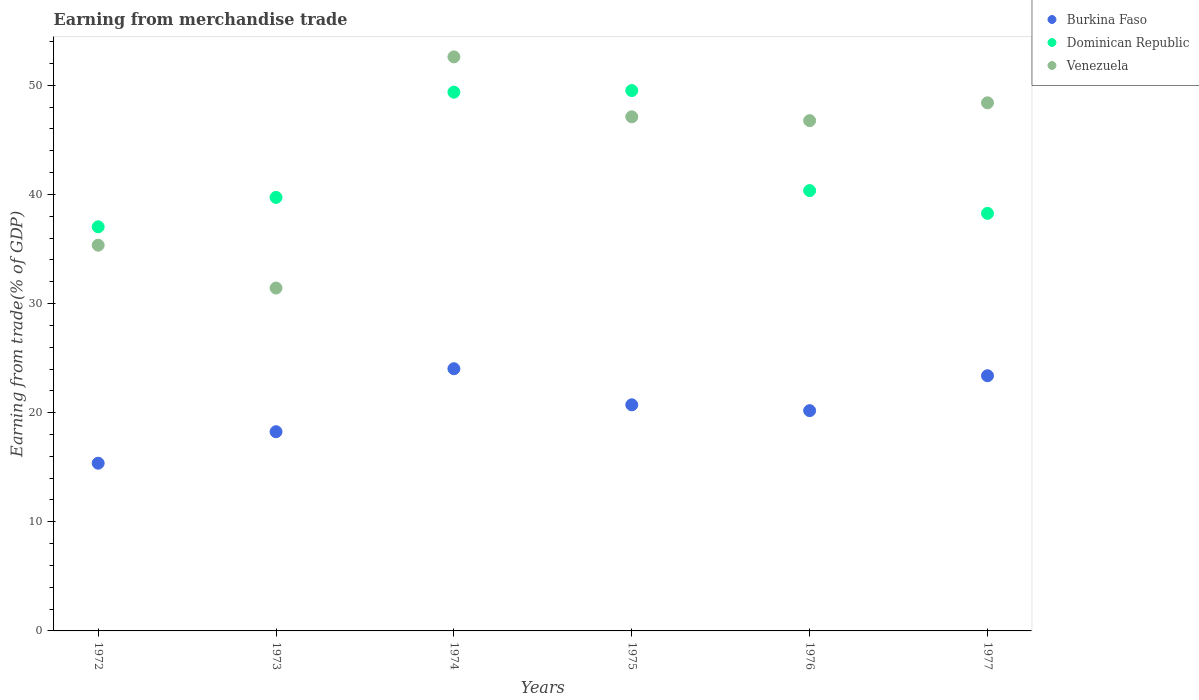What is the earnings from trade in Dominican Republic in 1975?
Provide a short and direct response. 49.52. Across all years, what is the maximum earnings from trade in Burkina Faso?
Provide a short and direct response. 24.03. Across all years, what is the minimum earnings from trade in Burkina Faso?
Offer a very short reply. 15.37. In which year was the earnings from trade in Dominican Republic maximum?
Your answer should be compact. 1975. What is the total earnings from trade in Burkina Faso in the graph?
Provide a short and direct response. 121.94. What is the difference between the earnings from trade in Venezuela in 1974 and that in 1975?
Ensure brevity in your answer.  5.49. What is the difference between the earnings from trade in Venezuela in 1976 and the earnings from trade in Burkina Faso in 1974?
Provide a short and direct response. 22.74. What is the average earnings from trade in Dominican Republic per year?
Provide a succinct answer. 42.38. In the year 1977, what is the difference between the earnings from trade in Venezuela and earnings from trade in Burkina Faso?
Keep it short and to the point. 25.01. What is the ratio of the earnings from trade in Burkina Faso in 1972 to that in 1976?
Offer a very short reply. 0.76. Is the difference between the earnings from trade in Venezuela in 1974 and 1976 greater than the difference between the earnings from trade in Burkina Faso in 1974 and 1976?
Provide a succinct answer. Yes. What is the difference between the highest and the second highest earnings from trade in Burkina Faso?
Ensure brevity in your answer.  0.64. What is the difference between the highest and the lowest earnings from trade in Dominican Republic?
Provide a succinct answer. 12.49. Is the sum of the earnings from trade in Venezuela in 1972 and 1976 greater than the maximum earnings from trade in Dominican Republic across all years?
Offer a terse response. Yes. Does the earnings from trade in Venezuela monotonically increase over the years?
Offer a terse response. No. How many dotlines are there?
Ensure brevity in your answer.  3. Does the graph contain grids?
Your response must be concise. No. What is the title of the graph?
Your answer should be very brief. Earning from merchandise trade. Does "Denmark" appear as one of the legend labels in the graph?
Keep it short and to the point. No. What is the label or title of the X-axis?
Provide a succinct answer. Years. What is the label or title of the Y-axis?
Make the answer very short. Earning from trade(% of GDP). What is the Earning from trade(% of GDP) of Burkina Faso in 1972?
Offer a terse response. 15.37. What is the Earning from trade(% of GDP) of Dominican Republic in 1972?
Keep it short and to the point. 37.03. What is the Earning from trade(% of GDP) of Venezuela in 1972?
Your answer should be compact. 35.35. What is the Earning from trade(% of GDP) in Burkina Faso in 1973?
Your response must be concise. 18.26. What is the Earning from trade(% of GDP) in Dominican Republic in 1973?
Provide a succinct answer. 39.73. What is the Earning from trade(% of GDP) of Venezuela in 1973?
Give a very brief answer. 31.42. What is the Earning from trade(% of GDP) of Burkina Faso in 1974?
Give a very brief answer. 24.03. What is the Earning from trade(% of GDP) of Dominican Republic in 1974?
Ensure brevity in your answer.  49.37. What is the Earning from trade(% of GDP) in Venezuela in 1974?
Offer a very short reply. 52.6. What is the Earning from trade(% of GDP) of Burkina Faso in 1975?
Your response must be concise. 20.72. What is the Earning from trade(% of GDP) in Dominican Republic in 1975?
Offer a terse response. 49.52. What is the Earning from trade(% of GDP) of Venezuela in 1975?
Provide a succinct answer. 47.11. What is the Earning from trade(% of GDP) of Burkina Faso in 1976?
Offer a terse response. 20.19. What is the Earning from trade(% of GDP) in Dominican Republic in 1976?
Provide a short and direct response. 40.35. What is the Earning from trade(% of GDP) in Venezuela in 1976?
Your answer should be compact. 46.76. What is the Earning from trade(% of GDP) of Burkina Faso in 1977?
Your response must be concise. 23.38. What is the Earning from trade(% of GDP) in Dominican Republic in 1977?
Your answer should be very brief. 38.27. What is the Earning from trade(% of GDP) in Venezuela in 1977?
Offer a very short reply. 48.39. Across all years, what is the maximum Earning from trade(% of GDP) in Burkina Faso?
Provide a succinct answer. 24.03. Across all years, what is the maximum Earning from trade(% of GDP) in Dominican Republic?
Provide a succinct answer. 49.52. Across all years, what is the maximum Earning from trade(% of GDP) of Venezuela?
Offer a very short reply. 52.6. Across all years, what is the minimum Earning from trade(% of GDP) in Burkina Faso?
Offer a very short reply. 15.37. Across all years, what is the minimum Earning from trade(% of GDP) in Dominican Republic?
Your response must be concise. 37.03. Across all years, what is the minimum Earning from trade(% of GDP) of Venezuela?
Offer a very short reply. 31.42. What is the total Earning from trade(% of GDP) in Burkina Faso in the graph?
Your answer should be very brief. 121.94. What is the total Earning from trade(% of GDP) of Dominican Republic in the graph?
Keep it short and to the point. 254.27. What is the total Earning from trade(% of GDP) of Venezuela in the graph?
Your answer should be compact. 261.65. What is the difference between the Earning from trade(% of GDP) in Burkina Faso in 1972 and that in 1973?
Make the answer very short. -2.89. What is the difference between the Earning from trade(% of GDP) of Dominican Republic in 1972 and that in 1973?
Your response must be concise. -2.7. What is the difference between the Earning from trade(% of GDP) of Venezuela in 1972 and that in 1973?
Your response must be concise. 3.93. What is the difference between the Earning from trade(% of GDP) in Burkina Faso in 1972 and that in 1974?
Give a very brief answer. -8.66. What is the difference between the Earning from trade(% of GDP) in Dominican Republic in 1972 and that in 1974?
Ensure brevity in your answer.  -12.34. What is the difference between the Earning from trade(% of GDP) in Venezuela in 1972 and that in 1974?
Keep it short and to the point. -17.26. What is the difference between the Earning from trade(% of GDP) in Burkina Faso in 1972 and that in 1975?
Keep it short and to the point. -5.35. What is the difference between the Earning from trade(% of GDP) in Dominican Republic in 1972 and that in 1975?
Provide a short and direct response. -12.49. What is the difference between the Earning from trade(% of GDP) in Venezuela in 1972 and that in 1975?
Make the answer very short. -11.76. What is the difference between the Earning from trade(% of GDP) in Burkina Faso in 1972 and that in 1976?
Give a very brief answer. -4.82. What is the difference between the Earning from trade(% of GDP) of Dominican Republic in 1972 and that in 1976?
Keep it short and to the point. -3.32. What is the difference between the Earning from trade(% of GDP) in Venezuela in 1972 and that in 1976?
Your answer should be compact. -11.41. What is the difference between the Earning from trade(% of GDP) in Burkina Faso in 1972 and that in 1977?
Make the answer very short. -8.02. What is the difference between the Earning from trade(% of GDP) in Dominican Republic in 1972 and that in 1977?
Provide a succinct answer. -1.23. What is the difference between the Earning from trade(% of GDP) of Venezuela in 1972 and that in 1977?
Provide a succinct answer. -13.05. What is the difference between the Earning from trade(% of GDP) of Burkina Faso in 1973 and that in 1974?
Offer a very short reply. -5.77. What is the difference between the Earning from trade(% of GDP) in Dominican Republic in 1973 and that in 1974?
Provide a succinct answer. -9.64. What is the difference between the Earning from trade(% of GDP) in Venezuela in 1973 and that in 1974?
Offer a terse response. -21.18. What is the difference between the Earning from trade(% of GDP) of Burkina Faso in 1973 and that in 1975?
Offer a very short reply. -2.46. What is the difference between the Earning from trade(% of GDP) of Dominican Republic in 1973 and that in 1975?
Give a very brief answer. -9.79. What is the difference between the Earning from trade(% of GDP) in Venezuela in 1973 and that in 1975?
Your answer should be compact. -15.69. What is the difference between the Earning from trade(% of GDP) in Burkina Faso in 1973 and that in 1976?
Give a very brief answer. -1.93. What is the difference between the Earning from trade(% of GDP) of Dominican Republic in 1973 and that in 1976?
Make the answer very short. -0.62. What is the difference between the Earning from trade(% of GDP) of Venezuela in 1973 and that in 1976?
Offer a very short reply. -15.34. What is the difference between the Earning from trade(% of GDP) of Burkina Faso in 1973 and that in 1977?
Provide a short and direct response. -5.13. What is the difference between the Earning from trade(% of GDP) in Dominican Republic in 1973 and that in 1977?
Ensure brevity in your answer.  1.46. What is the difference between the Earning from trade(% of GDP) of Venezuela in 1973 and that in 1977?
Offer a terse response. -16.97. What is the difference between the Earning from trade(% of GDP) in Burkina Faso in 1974 and that in 1975?
Make the answer very short. 3.31. What is the difference between the Earning from trade(% of GDP) of Dominican Republic in 1974 and that in 1975?
Offer a very short reply. -0.15. What is the difference between the Earning from trade(% of GDP) of Venezuela in 1974 and that in 1975?
Ensure brevity in your answer.  5.49. What is the difference between the Earning from trade(% of GDP) in Burkina Faso in 1974 and that in 1976?
Your answer should be compact. 3.84. What is the difference between the Earning from trade(% of GDP) in Dominican Republic in 1974 and that in 1976?
Offer a very short reply. 9.02. What is the difference between the Earning from trade(% of GDP) of Venezuela in 1974 and that in 1976?
Your answer should be very brief. 5.84. What is the difference between the Earning from trade(% of GDP) in Burkina Faso in 1974 and that in 1977?
Give a very brief answer. 0.64. What is the difference between the Earning from trade(% of GDP) of Dominican Republic in 1974 and that in 1977?
Give a very brief answer. 11.11. What is the difference between the Earning from trade(% of GDP) of Venezuela in 1974 and that in 1977?
Offer a very short reply. 4.21. What is the difference between the Earning from trade(% of GDP) of Burkina Faso in 1975 and that in 1976?
Offer a very short reply. 0.53. What is the difference between the Earning from trade(% of GDP) in Dominican Republic in 1975 and that in 1976?
Ensure brevity in your answer.  9.17. What is the difference between the Earning from trade(% of GDP) of Venezuela in 1975 and that in 1976?
Offer a terse response. 0.35. What is the difference between the Earning from trade(% of GDP) in Burkina Faso in 1975 and that in 1977?
Your answer should be very brief. -2.66. What is the difference between the Earning from trade(% of GDP) of Dominican Republic in 1975 and that in 1977?
Your answer should be compact. 11.25. What is the difference between the Earning from trade(% of GDP) of Venezuela in 1975 and that in 1977?
Your answer should be compact. -1.28. What is the difference between the Earning from trade(% of GDP) in Burkina Faso in 1976 and that in 1977?
Offer a terse response. -3.2. What is the difference between the Earning from trade(% of GDP) of Dominican Republic in 1976 and that in 1977?
Provide a succinct answer. 2.09. What is the difference between the Earning from trade(% of GDP) in Venezuela in 1976 and that in 1977?
Offer a very short reply. -1.63. What is the difference between the Earning from trade(% of GDP) of Burkina Faso in 1972 and the Earning from trade(% of GDP) of Dominican Republic in 1973?
Provide a succinct answer. -24.36. What is the difference between the Earning from trade(% of GDP) in Burkina Faso in 1972 and the Earning from trade(% of GDP) in Venezuela in 1973?
Offer a very short reply. -16.05. What is the difference between the Earning from trade(% of GDP) of Dominican Republic in 1972 and the Earning from trade(% of GDP) of Venezuela in 1973?
Your answer should be compact. 5.61. What is the difference between the Earning from trade(% of GDP) of Burkina Faso in 1972 and the Earning from trade(% of GDP) of Dominican Republic in 1974?
Ensure brevity in your answer.  -34. What is the difference between the Earning from trade(% of GDP) in Burkina Faso in 1972 and the Earning from trade(% of GDP) in Venezuela in 1974?
Provide a succinct answer. -37.24. What is the difference between the Earning from trade(% of GDP) in Dominican Republic in 1972 and the Earning from trade(% of GDP) in Venezuela in 1974?
Your response must be concise. -15.57. What is the difference between the Earning from trade(% of GDP) of Burkina Faso in 1972 and the Earning from trade(% of GDP) of Dominican Republic in 1975?
Ensure brevity in your answer.  -34.15. What is the difference between the Earning from trade(% of GDP) in Burkina Faso in 1972 and the Earning from trade(% of GDP) in Venezuela in 1975?
Give a very brief answer. -31.74. What is the difference between the Earning from trade(% of GDP) in Dominican Republic in 1972 and the Earning from trade(% of GDP) in Venezuela in 1975?
Make the answer very short. -10.08. What is the difference between the Earning from trade(% of GDP) in Burkina Faso in 1972 and the Earning from trade(% of GDP) in Dominican Republic in 1976?
Provide a short and direct response. -24.98. What is the difference between the Earning from trade(% of GDP) of Burkina Faso in 1972 and the Earning from trade(% of GDP) of Venezuela in 1976?
Your answer should be very brief. -31.39. What is the difference between the Earning from trade(% of GDP) of Dominican Republic in 1972 and the Earning from trade(% of GDP) of Venezuela in 1976?
Make the answer very short. -9.73. What is the difference between the Earning from trade(% of GDP) in Burkina Faso in 1972 and the Earning from trade(% of GDP) in Dominican Republic in 1977?
Offer a terse response. -22.9. What is the difference between the Earning from trade(% of GDP) of Burkina Faso in 1972 and the Earning from trade(% of GDP) of Venezuela in 1977?
Your response must be concise. -33.03. What is the difference between the Earning from trade(% of GDP) of Dominican Republic in 1972 and the Earning from trade(% of GDP) of Venezuela in 1977?
Offer a very short reply. -11.36. What is the difference between the Earning from trade(% of GDP) of Burkina Faso in 1973 and the Earning from trade(% of GDP) of Dominican Republic in 1974?
Your answer should be very brief. -31.12. What is the difference between the Earning from trade(% of GDP) in Burkina Faso in 1973 and the Earning from trade(% of GDP) in Venezuela in 1974?
Provide a succinct answer. -34.35. What is the difference between the Earning from trade(% of GDP) in Dominican Republic in 1973 and the Earning from trade(% of GDP) in Venezuela in 1974?
Offer a terse response. -12.88. What is the difference between the Earning from trade(% of GDP) of Burkina Faso in 1973 and the Earning from trade(% of GDP) of Dominican Republic in 1975?
Make the answer very short. -31.26. What is the difference between the Earning from trade(% of GDP) in Burkina Faso in 1973 and the Earning from trade(% of GDP) in Venezuela in 1975?
Offer a very short reply. -28.86. What is the difference between the Earning from trade(% of GDP) of Dominican Republic in 1973 and the Earning from trade(% of GDP) of Venezuela in 1975?
Provide a succinct answer. -7.39. What is the difference between the Earning from trade(% of GDP) of Burkina Faso in 1973 and the Earning from trade(% of GDP) of Dominican Republic in 1976?
Ensure brevity in your answer.  -22.1. What is the difference between the Earning from trade(% of GDP) in Burkina Faso in 1973 and the Earning from trade(% of GDP) in Venezuela in 1976?
Provide a succinct answer. -28.51. What is the difference between the Earning from trade(% of GDP) in Dominican Republic in 1973 and the Earning from trade(% of GDP) in Venezuela in 1976?
Offer a very short reply. -7.04. What is the difference between the Earning from trade(% of GDP) in Burkina Faso in 1973 and the Earning from trade(% of GDP) in Dominican Republic in 1977?
Provide a short and direct response. -20.01. What is the difference between the Earning from trade(% of GDP) in Burkina Faso in 1973 and the Earning from trade(% of GDP) in Venezuela in 1977?
Provide a short and direct response. -30.14. What is the difference between the Earning from trade(% of GDP) of Dominican Republic in 1973 and the Earning from trade(% of GDP) of Venezuela in 1977?
Provide a succinct answer. -8.67. What is the difference between the Earning from trade(% of GDP) of Burkina Faso in 1974 and the Earning from trade(% of GDP) of Dominican Republic in 1975?
Offer a very short reply. -25.49. What is the difference between the Earning from trade(% of GDP) of Burkina Faso in 1974 and the Earning from trade(% of GDP) of Venezuela in 1975?
Provide a succinct answer. -23.09. What is the difference between the Earning from trade(% of GDP) in Dominican Republic in 1974 and the Earning from trade(% of GDP) in Venezuela in 1975?
Provide a succinct answer. 2.26. What is the difference between the Earning from trade(% of GDP) in Burkina Faso in 1974 and the Earning from trade(% of GDP) in Dominican Republic in 1976?
Your response must be concise. -16.33. What is the difference between the Earning from trade(% of GDP) of Burkina Faso in 1974 and the Earning from trade(% of GDP) of Venezuela in 1976?
Offer a terse response. -22.74. What is the difference between the Earning from trade(% of GDP) in Dominican Republic in 1974 and the Earning from trade(% of GDP) in Venezuela in 1976?
Your response must be concise. 2.61. What is the difference between the Earning from trade(% of GDP) of Burkina Faso in 1974 and the Earning from trade(% of GDP) of Dominican Republic in 1977?
Your response must be concise. -14.24. What is the difference between the Earning from trade(% of GDP) of Burkina Faso in 1974 and the Earning from trade(% of GDP) of Venezuela in 1977?
Offer a terse response. -24.37. What is the difference between the Earning from trade(% of GDP) of Dominican Republic in 1974 and the Earning from trade(% of GDP) of Venezuela in 1977?
Your answer should be compact. 0.98. What is the difference between the Earning from trade(% of GDP) in Burkina Faso in 1975 and the Earning from trade(% of GDP) in Dominican Republic in 1976?
Keep it short and to the point. -19.63. What is the difference between the Earning from trade(% of GDP) in Burkina Faso in 1975 and the Earning from trade(% of GDP) in Venezuela in 1976?
Your response must be concise. -26.04. What is the difference between the Earning from trade(% of GDP) of Dominican Republic in 1975 and the Earning from trade(% of GDP) of Venezuela in 1976?
Your response must be concise. 2.76. What is the difference between the Earning from trade(% of GDP) in Burkina Faso in 1975 and the Earning from trade(% of GDP) in Dominican Republic in 1977?
Ensure brevity in your answer.  -17.55. What is the difference between the Earning from trade(% of GDP) in Burkina Faso in 1975 and the Earning from trade(% of GDP) in Venezuela in 1977?
Offer a terse response. -27.67. What is the difference between the Earning from trade(% of GDP) of Dominican Republic in 1975 and the Earning from trade(% of GDP) of Venezuela in 1977?
Make the answer very short. 1.13. What is the difference between the Earning from trade(% of GDP) in Burkina Faso in 1976 and the Earning from trade(% of GDP) in Dominican Republic in 1977?
Your response must be concise. -18.08. What is the difference between the Earning from trade(% of GDP) of Burkina Faso in 1976 and the Earning from trade(% of GDP) of Venezuela in 1977?
Offer a very short reply. -28.21. What is the difference between the Earning from trade(% of GDP) in Dominican Republic in 1976 and the Earning from trade(% of GDP) in Venezuela in 1977?
Your answer should be very brief. -8.04. What is the average Earning from trade(% of GDP) in Burkina Faso per year?
Provide a short and direct response. 20.32. What is the average Earning from trade(% of GDP) of Dominican Republic per year?
Make the answer very short. 42.38. What is the average Earning from trade(% of GDP) in Venezuela per year?
Ensure brevity in your answer.  43.61. In the year 1972, what is the difference between the Earning from trade(% of GDP) of Burkina Faso and Earning from trade(% of GDP) of Dominican Republic?
Offer a very short reply. -21.66. In the year 1972, what is the difference between the Earning from trade(% of GDP) in Burkina Faso and Earning from trade(% of GDP) in Venezuela?
Keep it short and to the point. -19.98. In the year 1972, what is the difference between the Earning from trade(% of GDP) in Dominican Republic and Earning from trade(% of GDP) in Venezuela?
Ensure brevity in your answer.  1.68. In the year 1973, what is the difference between the Earning from trade(% of GDP) of Burkina Faso and Earning from trade(% of GDP) of Dominican Republic?
Your answer should be compact. -21.47. In the year 1973, what is the difference between the Earning from trade(% of GDP) of Burkina Faso and Earning from trade(% of GDP) of Venezuela?
Provide a succinct answer. -13.17. In the year 1973, what is the difference between the Earning from trade(% of GDP) of Dominican Republic and Earning from trade(% of GDP) of Venezuela?
Provide a succinct answer. 8.31. In the year 1974, what is the difference between the Earning from trade(% of GDP) in Burkina Faso and Earning from trade(% of GDP) in Dominican Republic?
Provide a succinct answer. -25.34. In the year 1974, what is the difference between the Earning from trade(% of GDP) in Burkina Faso and Earning from trade(% of GDP) in Venezuela?
Make the answer very short. -28.58. In the year 1974, what is the difference between the Earning from trade(% of GDP) of Dominican Republic and Earning from trade(% of GDP) of Venezuela?
Your answer should be compact. -3.23. In the year 1975, what is the difference between the Earning from trade(% of GDP) of Burkina Faso and Earning from trade(% of GDP) of Dominican Republic?
Make the answer very short. -28.8. In the year 1975, what is the difference between the Earning from trade(% of GDP) of Burkina Faso and Earning from trade(% of GDP) of Venezuela?
Your response must be concise. -26.39. In the year 1975, what is the difference between the Earning from trade(% of GDP) in Dominican Republic and Earning from trade(% of GDP) in Venezuela?
Offer a terse response. 2.41. In the year 1976, what is the difference between the Earning from trade(% of GDP) of Burkina Faso and Earning from trade(% of GDP) of Dominican Republic?
Provide a succinct answer. -20.17. In the year 1976, what is the difference between the Earning from trade(% of GDP) of Burkina Faso and Earning from trade(% of GDP) of Venezuela?
Make the answer very short. -26.58. In the year 1976, what is the difference between the Earning from trade(% of GDP) in Dominican Republic and Earning from trade(% of GDP) in Venezuela?
Your response must be concise. -6.41. In the year 1977, what is the difference between the Earning from trade(% of GDP) in Burkina Faso and Earning from trade(% of GDP) in Dominican Republic?
Give a very brief answer. -14.88. In the year 1977, what is the difference between the Earning from trade(% of GDP) of Burkina Faso and Earning from trade(% of GDP) of Venezuela?
Provide a succinct answer. -25.01. In the year 1977, what is the difference between the Earning from trade(% of GDP) in Dominican Republic and Earning from trade(% of GDP) in Venezuela?
Your answer should be very brief. -10.13. What is the ratio of the Earning from trade(% of GDP) of Burkina Faso in 1972 to that in 1973?
Keep it short and to the point. 0.84. What is the ratio of the Earning from trade(% of GDP) in Dominican Republic in 1972 to that in 1973?
Provide a succinct answer. 0.93. What is the ratio of the Earning from trade(% of GDP) of Burkina Faso in 1972 to that in 1974?
Offer a very short reply. 0.64. What is the ratio of the Earning from trade(% of GDP) in Dominican Republic in 1972 to that in 1974?
Give a very brief answer. 0.75. What is the ratio of the Earning from trade(% of GDP) of Venezuela in 1972 to that in 1974?
Make the answer very short. 0.67. What is the ratio of the Earning from trade(% of GDP) in Burkina Faso in 1972 to that in 1975?
Offer a terse response. 0.74. What is the ratio of the Earning from trade(% of GDP) of Dominican Republic in 1972 to that in 1975?
Ensure brevity in your answer.  0.75. What is the ratio of the Earning from trade(% of GDP) in Venezuela in 1972 to that in 1975?
Provide a succinct answer. 0.75. What is the ratio of the Earning from trade(% of GDP) in Burkina Faso in 1972 to that in 1976?
Your response must be concise. 0.76. What is the ratio of the Earning from trade(% of GDP) in Dominican Republic in 1972 to that in 1976?
Provide a short and direct response. 0.92. What is the ratio of the Earning from trade(% of GDP) of Venezuela in 1972 to that in 1976?
Make the answer very short. 0.76. What is the ratio of the Earning from trade(% of GDP) in Burkina Faso in 1972 to that in 1977?
Ensure brevity in your answer.  0.66. What is the ratio of the Earning from trade(% of GDP) in Dominican Republic in 1972 to that in 1977?
Your answer should be very brief. 0.97. What is the ratio of the Earning from trade(% of GDP) in Venezuela in 1972 to that in 1977?
Provide a short and direct response. 0.73. What is the ratio of the Earning from trade(% of GDP) of Burkina Faso in 1973 to that in 1974?
Your answer should be compact. 0.76. What is the ratio of the Earning from trade(% of GDP) in Dominican Republic in 1973 to that in 1974?
Make the answer very short. 0.8. What is the ratio of the Earning from trade(% of GDP) of Venezuela in 1973 to that in 1974?
Your answer should be very brief. 0.6. What is the ratio of the Earning from trade(% of GDP) of Burkina Faso in 1973 to that in 1975?
Your answer should be very brief. 0.88. What is the ratio of the Earning from trade(% of GDP) of Dominican Republic in 1973 to that in 1975?
Give a very brief answer. 0.8. What is the ratio of the Earning from trade(% of GDP) of Venezuela in 1973 to that in 1975?
Make the answer very short. 0.67. What is the ratio of the Earning from trade(% of GDP) in Burkina Faso in 1973 to that in 1976?
Keep it short and to the point. 0.9. What is the ratio of the Earning from trade(% of GDP) in Dominican Republic in 1973 to that in 1976?
Your answer should be compact. 0.98. What is the ratio of the Earning from trade(% of GDP) in Venezuela in 1973 to that in 1976?
Keep it short and to the point. 0.67. What is the ratio of the Earning from trade(% of GDP) of Burkina Faso in 1973 to that in 1977?
Keep it short and to the point. 0.78. What is the ratio of the Earning from trade(% of GDP) in Dominican Republic in 1973 to that in 1977?
Make the answer very short. 1.04. What is the ratio of the Earning from trade(% of GDP) of Venezuela in 1973 to that in 1977?
Give a very brief answer. 0.65. What is the ratio of the Earning from trade(% of GDP) in Burkina Faso in 1974 to that in 1975?
Ensure brevity in your answer.  1.16. What is the ratio of the Earning from trade(% of GDP) in Dominican Republic in 1974 to that in 1975?
Make the answer very short. 1. What is the ratio of the Earning from trade(% of GDP) in Venezuela in 1974 to that in 1975?
Give a very brief answer. 1.12. What is the ratio of the Earning from trade(% of GDP) of Burkina Faso in 1974 to that in 1976?
Offer a terse response. 1.19. What is the ratio of the Earning from trade(% of GDP) of Dominican Republic in 1974 to that in 1976?
Give a very brief answer. 1.22. What is the ratio of the Earning from trade(% of GDP) of Venezuela in 1974 to that in 1976?
Ensure brevity in your answer.  1.12. What is the ratio of the Earning from trade(% of GDP) of Burkina Faso in 1974 to that in 1977?
Provide a succinct answer. 1.03. What is the ratio of the Earning from trade(% of GDP) in Dominican Republic in 1974 to that in 1977?
Give a very brief answer. 1.29. What is the ratio of the Earning from trade(% of GDP) of Venezuela in 1974 to that in 1977?
Offer a very short reply. 1.09. What is the ratio of the Earning from trade(% of GDP) in Burkina Faso in 1975 to that in 1976?
Make the answer very short. 1.03. What is the ratio of the Earning from trade(% of GDP) of Dominican Republic in 1975 to that in 1976?
Provide a short and direct response. 1.23. What is the ratio of the Earning from trade(% of GDP) in Venezuela in 1975 to that in 1976?
Your answer should be compact. 1.01. What is the ratio of the Earning from trade(% of GDP) of Burkina Faso in 1975 to that in 1977?
Offer a terse response. 0.89. What is the ratio of the Earning from trade(% of GDP) in Dominican Republic in 1975 to that in 1977?
Provide a short and direct response. 1.29. What is the ratio of the Earning from trade(% of GDP) of Venezuela in 1975 to that in 1977?
Keep it short and to the point. 0.97. What is the ratio of the Earning from trade(% of GDP) of Burkina Faso in 1976 to that in 1977?
Provide a succinct answer. 0.86. What is the ratio of the Earning from trade(% of GDP) in Dominican Republic in 1976 to that in 1977?
Give a very brief answer. 1.05. What is the ratio of the Earning from trade(% of GDP) in Venezuela in 1976 to that in 1977?
Your response must be concise. 0.97. What is the difference between the highest and the second highest Earning from trade(% of GDP) in Burkina Faso?
Keep it short and to the point. 0.64. What is the difference between the highest and the second highest Earning from trade(% of GDP) of Dominican Republic?
Make the answer very short. 0.15. What is the difference between the highest and the second highest Earning from trade(% of GDP) in Venezuela?
Give a very brief answer. 4.21. What is the difference between the highest and the lowest Earning from trade(% of GDP) of Burkina Faso?
Keep it short and to the point. 8.66. What is the difference between the highest and the lowest Earning from trade(% of GDP) of Dominican Republic?
Keep it short and to the point. 12.49. What is the difference between the highest and the lowest Earning from trade(% of GDP) of Venezuela?
Offer a very short reply. 21.18. 